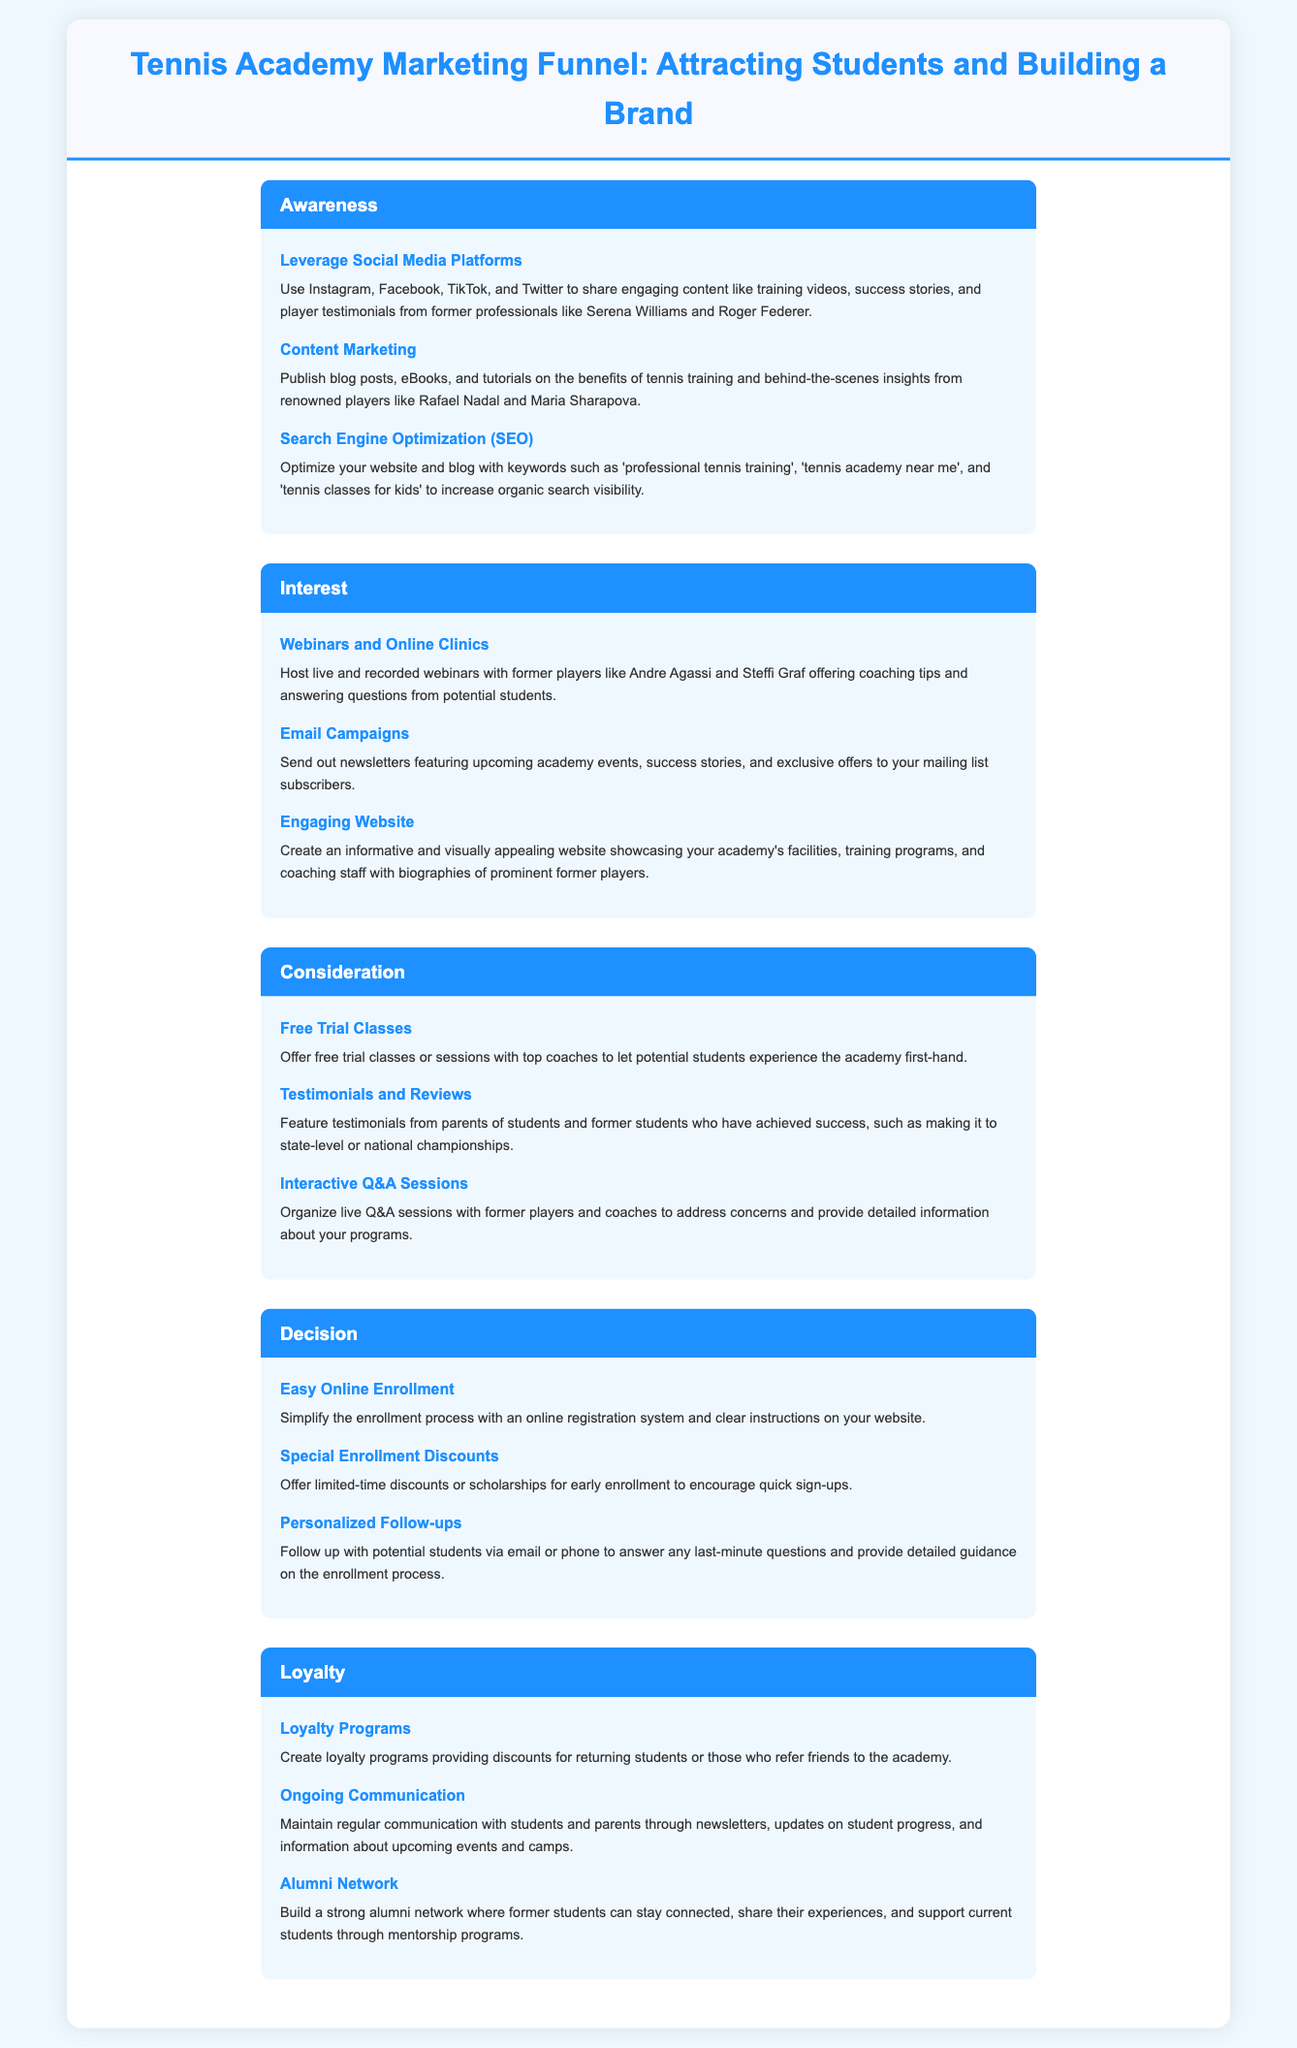What is the first stage of the marketing funnel? The first stage is called Awareness.
Answer: Awareness Who can be featured in testimonials according to the document? Testimonials can feature parents of students and former students.
Answer: Parents and former students What type of campaigns should be sent out via email? Email campaigns should include newsletters featuring academy events, success stories, and exclusive offers.
Answer: Newsletters What offers are made during the Decision stage? Special Enrollment Discounts are offered during the Decision stage.
Answer: Special Enrollment Discounts Which social media platforms are suggested for leveraging in the Awareness stage? Instagram, Facebook, TikTok, and Twitter are suggested.
Answer: Instagram, Facebook, TikTok, Twitter What is a strategy to maintain student engagement after enrollment? Ongoing communication is a strategy to maintain engagement.
Answer: Ongoing communication Name a former player mentioned for webinar participation. Andre Agassi is mentioned for webinars.
Answer: Andre Agassi What method is suggested for simplifying the enrollment process? An online registration system is suggested for simplification.
Answer: Online registration system How should the website be characterized for the Interest stage? The website should be informative and visually appealing.
Answer: Informative and visually appealing 